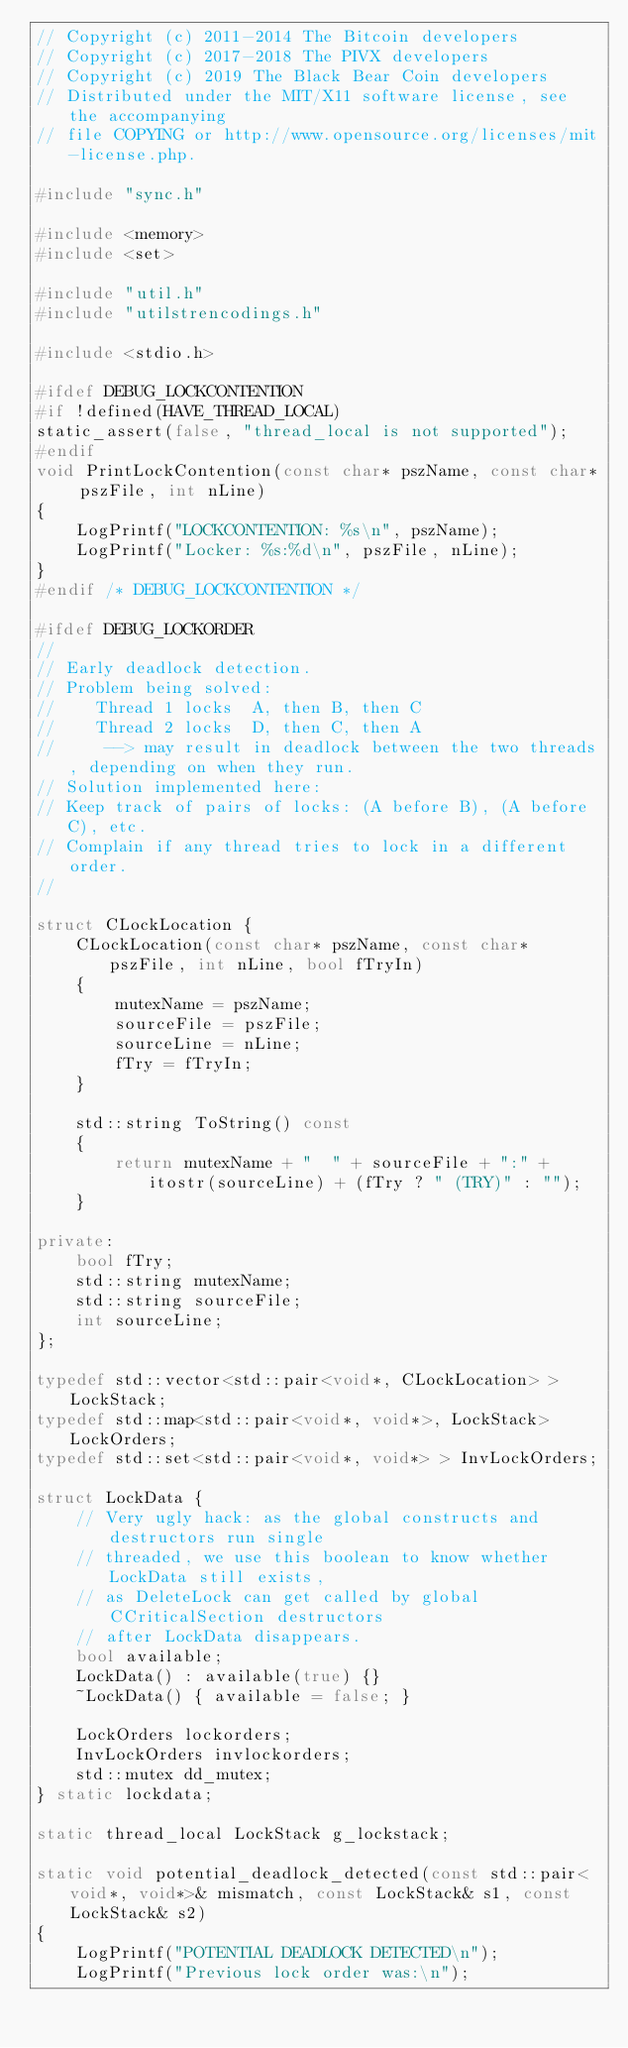<code> <loc_0><loc_0><loc_500><loc_500><_C++_>// Copyright (c) 2011-2014 The Bitcoin developers
// Copyright (c) 2017-2018 The PIVX developers
// Copyright (c) 2019 The Black Bear Coin developers
// Distributed under the MIT/X11 software license, see the accompanying
// file COPYING or http://www.opensource.org/licenses/mit-license.php.

#include "sync.h"

#include <memory>
#include <set>

#include "util.h"
#include "utilstrencodings.h"

#include <stdio.h>

#ifdef DEBUG_LOCKCONTENTION
#if !defined(HAVE_THREAD_LOCAL)
static_assert(false, "thread_local is not supported");
#endif
void PrintLockContention(const char* pszName, const char* pszFile, int nLine)
{
    LogPrintf("LOCKCONTENTION: %s\n", pszName);
    LogPrintf("Locker: %s:%d\n", pszFile, nLine);
}
#endif /* DEBUG_LOCKCONTENTION */

#ifdef DEBUG_LOCKORDER
//
// Early deadlock detection.
// Problem being solved:
//    Thread 1 locks  A, then B, then C
//    Thread 2 locks  D, then C, then A
//     --> may result in deadlock between the two threads, depending on when they run.
// Solution implemented here:
// Keep track of pairs of locks: (A before B), (A before C), etc.
// Complain if any thread tries to lock in a different order.
//

struct CLockLocation {
    CLockLocation(const char* pszName, const char* pszFile, int nLine, bool fTryIn)
    {
        mutexName = pszName;
        sourceFile = pszFile;
        sourceLine = nLine;
        fTry = fTryIn;
    }

    std::string ToString() const
    {
        return mutexName + "  " + sourceFile + ":" + itostr(sourceLine) + (fTry ? " (TRY)" : "");
    }

private:
    bool fTry;
    std::string mutexName;
    std::string sourceFile;
    int sourceLine;
};

typedef std::vector<std::pair<void*, CLockLocation> > LockStack;
typedef std::map<std::pair<void*, void*>, LockStack> LockOrders;
typedef std::set<std::pair<void*, void*> > InvLockOrders;

struct LockData {
    // Very ugly hack: as the global constructs and destructors run single
    // threaded, we use this boolean to know whether LockData still exists,
    // as DeleteLock can get called by global CCriticalSection destructors
    // after LockData disappears.
    bool available;
    LockData() : available(true) {}
    ~LockData() { available = false; }

    LockOrders lockorders;
    InvLockOrders invlockorders;
    std::mutex dd_mutex;
} static lockdata;

static thread_local LockStack g_lockstack;

static void potential_deadlock_detected(const std::pair<void*, void*>& mismatch, const LockStack& s1, const LockStack& s2)
{
    LogPrintf("POTENTIAL DEADLOCK DETECTED\n");
    LogPrintf("Previous lock order was:\n");
</code> 